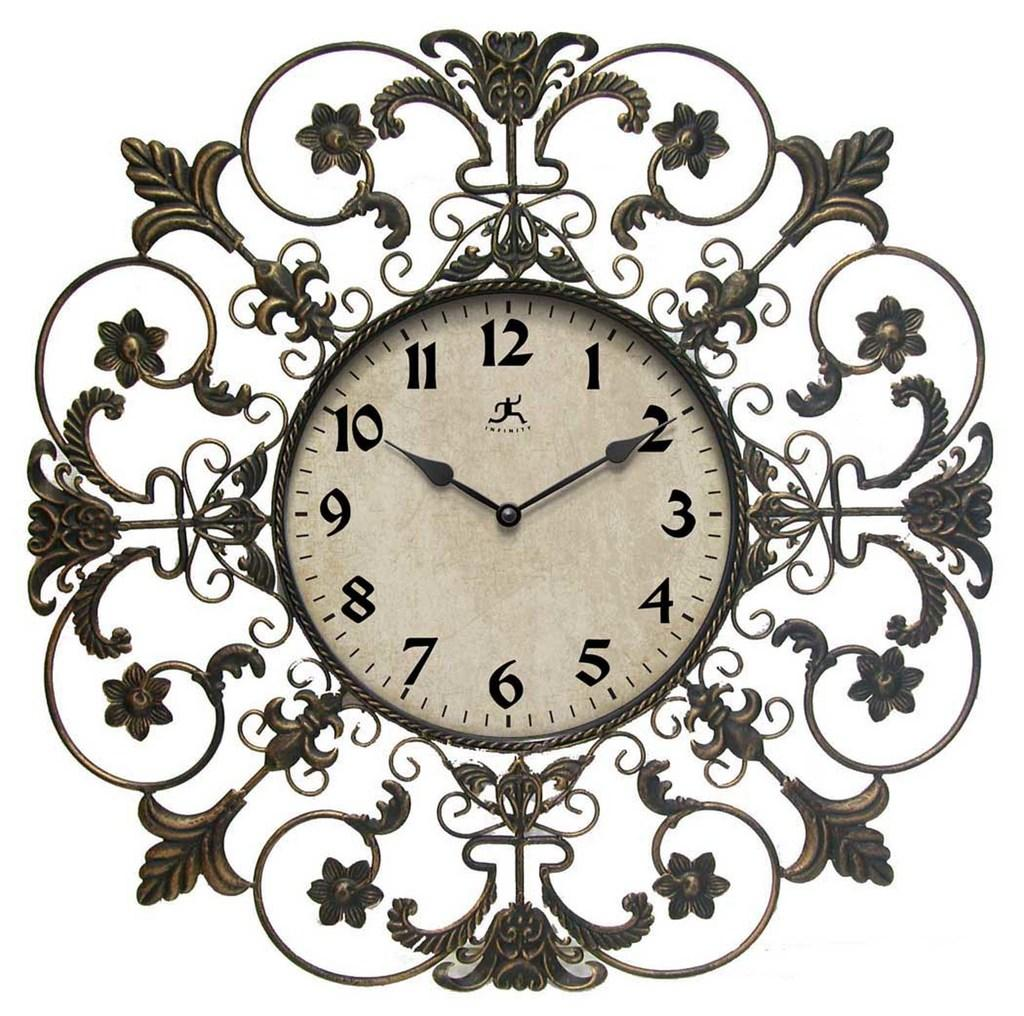<image>
Provide a brief description of the given image. A clock showing the the time is 10:10. 